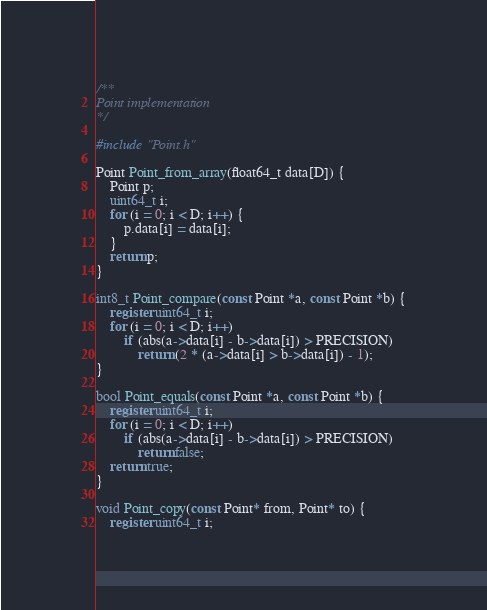<code> <loc_0><loc_0><loc_500><loc_500><_C_>/**
Point implementation
*/

#include "Point.h"

Point Point_from_array(float64_t data[D]) {
    Point p;
    uint64_t i;
    for (i = 0; i < D; i++) {
        p.data[i] = data[i];
    }
    return p;
}

int8_t Point_compare(const Point *a, const Point *b) {
    register uint64_t i;
    for (i = 0; i < D; i++)
        if (abs(a->data[i] - b->data[i]) > PRECISION)
            return (2 * (a->data[i] > b->data[i]) - 1);
}

bool Point_equals(const Point *a, const Point *b) {
    register uint64_t i;
    for (i = 0; i < D; i++)
        if (abs(a->data[i] - b->data[i]) > PRECISION)
            return false;
    return true;
}

void Point_copy(const Point* from, Point* to) {
    register uint64_t i;</code> 